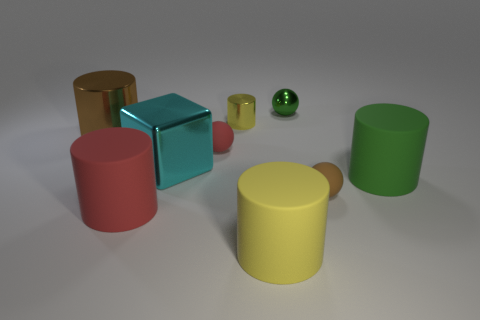Subtract all tiny metallic cylinders. How many cylinders are left? 4 Subtract all red cubes. Subtract all purple spheres. How many cubes are left? 1 Subtract all yellow cylinders. How many red balls are left? 1 Subtract all red matte balls. Subtract all large things. How many objects are left? 3 Add 1 small yellow cylinders. How many small yellow cylinders are left? 2 Add 5 metallic blocks. How many metallic blocks exist? 6 Subtract all green cylinders. How many cylinders are left? 4 Subtract 1 red balls. How many objects are left? 8 Subtract all cylinders. How many objects are left? 4 Subtract 4 cylinders. How many cylinders are left? 1 